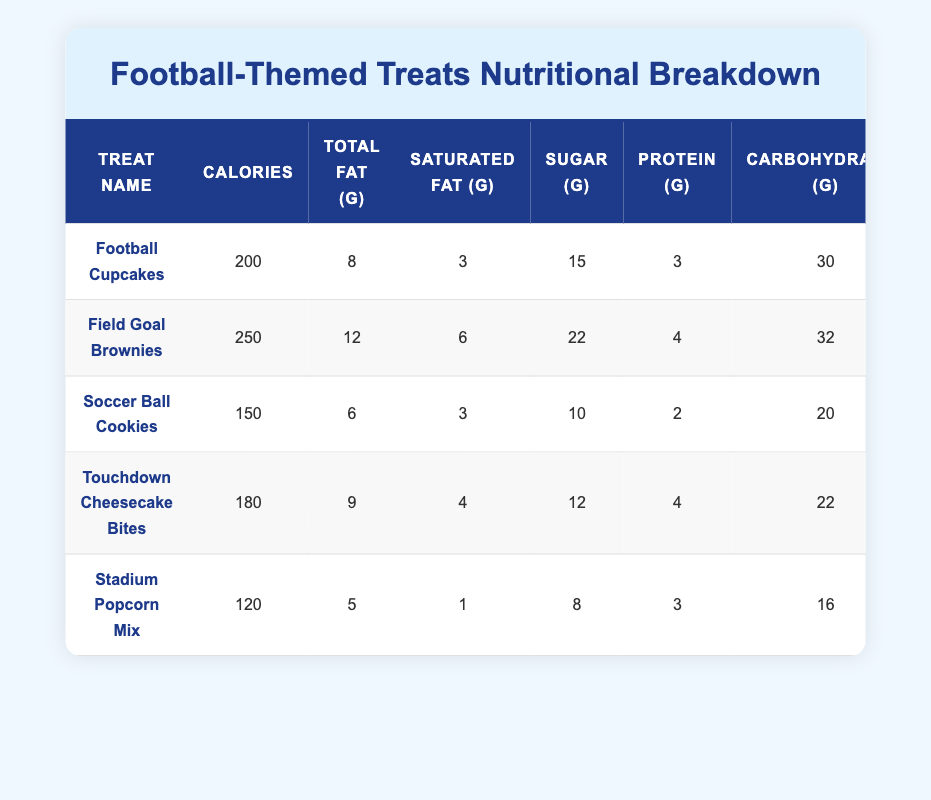What treat has the highest calorie count? Field Goal Brownies has the highest calorie count at 250 calories. This can be located in the "Calories" column of each treat, and Field Goal Brownies has the largest number among all the entries.
Answer: Field Goal Brownies How many grams of sugar are in Soccer Ball Cookies? The Soccer Ball Cookies contain 10 grams of sugar, which is found directly in the "Sugar (g)" column for that treat.
Answer: 10 What is the total fat content of Football Cupcakes and Touchdown Cheesecake Bites combined? The total fat content of Football Cupcakes is 8 grams and for Touchdown Cheesecake Bites it is 9 grams. Adding them together gives us 8 + 9 = 17 grams.
Answer: 17 grams Is the saturated fat content of Stadium Popcorn Mix less than that of Field Goal Brownies? Yes, Stadium Popcorn Mix has 1 gram of saturated fat, while Field Goal Brownies has 6 grams. Since 1 is less than 6, the statement is true.
Answer: Yes Which treat has the lowest carbohydrate content? Stadium Popcorn Mix has the lowest carbohydrate content at 16 grams, which can be found in the "Carbohydrates (g)" column for each treat and compared accordingly.
Answer: Stadium Popcorn Mix What’s the average calorie content of the treats listed? To find the average calorie content, add all the calories: 200 + 250 + 150 + 180 + 120 = 900. Then divide by the number of treats (5), which gives us 900 / 5 = 180.
Answer: 180 How does the sugar content of Football Cupcakes compare to Touchdown Cheesecake Bites? Football Cupcakes have 15 grams of sugar, while Touchdown Cheesecake Bites have 12 grams. Since 15 is greater than 12, Football Cupcakes have more sugar.
Answer: Football Cupcakes have more sugar Which treat provides the most protein per serving? Field Goal Brownies offers 4 grams of protein, which is the highest amount compared to other treats. This is found by checking the "Protein (g)" column and identifying the maximum.
Answer: Field Goal Brownies What is the difference in calories between Field Goal Brownies and Soccer Ball Cookies? Field Goal Brownies has 250 calories, and Soccer Ball Cookies has 150 calories. Subtracting these gives 250 - 150 = 100 calories.
Answer: 100 calories How many total carbohydrates do the Touchdown Cheesecake Bites and Field Goal Brownies have together? Touchdown Cheesecake Bites have 22 grams of carbohydrates, and Field Goal Brownies have 32 grams. Adding these gives 22 + 32 = 54 grams.
Answer: 54 grams 